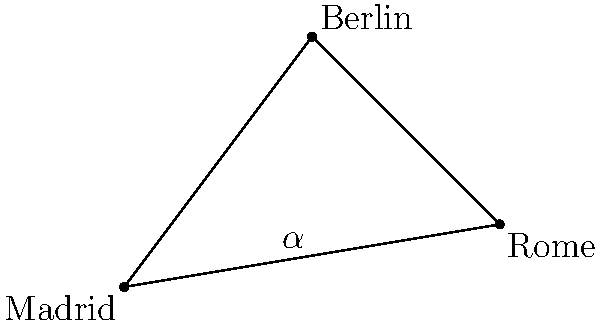On a map projection of Europe, Madrid, Berlin, and Rome form a triangle. If the angle at Madrid (labeled $\alpha$ in the diagram) is 53°, what is the sum of the other two angles in the triangle? To solve this problem, we need to follow these steps:

1. Recall the fundamental property of triangles: The sum of all angles in a triangle is always 180°.

2. We are given that the angle at Madrid ($\alpha$) is 53°.

3. Let's denote the other two angles as $\beta$ (at Berlin) and $\gamma$ (at Rome).

4. We can set up an equation:
   $\alpha + \beta + \gamma = 180°$

5. Substituting the known value:
   $53° + \beta + \gamma = 180°$

6. Rearranging the equation:
   $\beta + \gamma = 180° - 53°$

7. Simplifying:
   $\beta + \gamma = 127°$

Therefore, the sum of the angles at Berlin and Rome is 127°.
Answer: 127° 